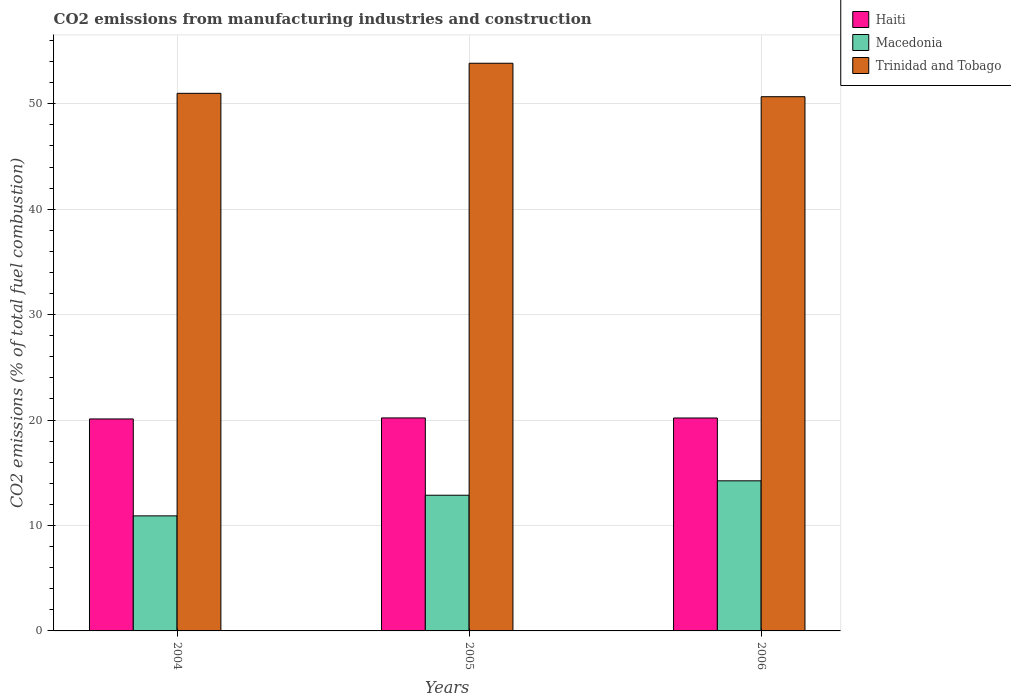How many different coloured bars are there?
Offer a terse response. 3. What is the amount of CO2 emitted in Trinidad and Tobago in 2006?
Keep it short and to the point. 50.67. Across all years, what is the maximum amount of CO2 emitted in Macedonia?
Offer a terse response. 14.24. Across all years, what is the minimum amount of CO2 emitted in Macedonia?
Make the answer very short. 10.91. In which year was the amount of CO2 emitted in Haiti maximum?
Your response must be concise. 2005. What is the total amount of CO2 emitted in Trinidad and Tobago in the graph?
Provide a short and direct response. 155.51. What is the difference between the amount of CO2 emitted in Macedonia in 2005 and that in 2006?
Ensure brevity in your answer.  -1.37. What is the difference between the amount of CO2 emitted in Macedonia in 2005 and the amount of CO2 emitted in Haiti in 2006?
Your response must be concise. -7.33. What is the average amount of CO2 emitted in Trinidad and Tobago per year?
Your answer should be very brief. 51.84. In the year 2005, what is the difference between the amount of CO2 emitted in Macedonia and amount of CO2 emitted in Haiti?
Your answer should be very brief. -7.33. In how many years, is the amount of CO2 emitted in Trinidad and Tobago greater than 48 %?
Offer a very short reply. 3. What is the ratio of the amount of CO2 emitted in Haiti in 2005 to that in 2006?
Offer a terse response. 1. What is the difference between the highest and the second highest amount of CO2 emitted in Macedonia?
Ensure brevity in your answer.  1.37. What is the difference between the highest and the lowest amount of CO2 emitted in Trinidad and Tobago?
Make the answer very short. 3.17. Is the sum of the amount of CO2 emitted in Macedonia in 2005 and 2006 greater than the maximum amount of CO2 emitted in Haiti across all years?
Provide a short and direct response. Yes. What does the 3rd bar from the left in 2004 represents?
Your answer should be compact. Trinidad and Tobago. What does the 2nd bar from the right in 2006 represents?
Your answer should be compact. Macedonia. Are all the bars in the graph horizontal?
Give a very brief answer. No. Are the values on the major ticks of Y-axis written in scientific E-notation?
Provide a succinct answer. No. Does the graph contain any zero values?
Offer a very short reply. No. Does the graph contain grids?
Give a very brief answer. Yes. Where does the legend appear in the graph?
Your response must be concise. Top right. How many legend labels are there?
Give a very brief answer. 3. How are the legend labels stacked?
Your answer should be very brief. Vertical. What is the title of the graph?
Make the answer very short. CO2 emissions from manufacturing industries and construction. What is the label or title of the X-axis?
Your answer should be compact. Years. What is the label or title of the Y-axis?
Provide a succinct answer. CO2 emissions (% of total fuel combustion). What is the CO2 emissions (% of total fuel combustion) in Haiti in 2004?
Your answer should be very brief. 20.11. What is the CO2 emissions (% of total fuel combustion) in Macedonia in 2004?
Provide a short and direct response. 10.91. What is the CO2 emissions (% of total fuel combustion) of Trinidad and Tobago in 2004?
Your answer should be very brief. 50.99. What is the CO2 emissions (% of total fuel combustion) of Haiti in 2005?
Your response must be concise. 20.2. What is the CO2 emissions (% of total fuel combustion) of Macedonia in 2005?
Your response must be concise. 12.87. What is the CO2 emissions (% of total fuel combustion) of Trinidad and Tobago in 2005?
Keep it short and to the point. 53.84. What is the CO2 emissions (% of total fuel combustion) in Haiti in 2006?
Make the answer very short. 20.2. What is the CO2 emissions (% of total fuel combustion) of Macedonia in 2006?
Ensure brevity in your answer.  14.24. What is the CO2 emissions (% of total fuel combustion) of Trinidad and Tobago in 2006?
Ensure brevity in your answer.  50.67. Across all years, what is the maximum CO2 emissions (% of total fuel combustion) in Haiti?
Make the answer very short. 20.2. Across all years, what is the maximum CO2 emissions (% of total fuel combustion) in Macedonia?
Keep it short and to the point. 14.24. Across all years, what is the maximum CO2 emissions (% of total fuel combustion) in Trinidad and Tobago?
Your answer should be compact. 53.84. Across all years, what is the minimum CO2 emissions (% of total fuel combustion) of Haiti?
Keep it short and to the point. 20.11. Across all years, what is the minimum CO2 emissions (% of total fuel combustion) in Macedonia?
Give a very brief answer. 10.91. Across all years, what is the minimum CO2 emissions (% of total fuel combustion) in Trinidad and Tobago?
Your answer should be very brief. 50.67. What is the total CO2 emissions (% of total fuel combustion) in Haiti in the graph?
Give a very brief answer. 60.5. What is the total CO2 emissions (% of total fuel combustion) of Macedonia in the graph?
Provide a succinct answer. 38.02. What is the total CO2 emissions (% of total fuel combustion) in Trinidad and Tobago in the graph?
Make the answer very short. 155.51. What is the difference between the CO2 emissions (% of total fuel combustion) in Haiti in 2004 and that in 2005?
Keep it short and to the point. -0.1. What is the difference between the CO2 emissions (% of total fuel combustion) of Macedonia in 2004 and that in 2005?
Make the answer very short. -1.96. What is the difference between the CO2 emissions (% of total fuel combustion) in Trinidad and Tobago in 2004 and that in 2005?
Offer a very short reply. -2.85. What is the difference between the CO2 emissions (% of total fuel combustion) of Haiti in 2004 and that in 2006?
Your answer should be very brief. -0.09. What is the difference between the CO2 emissions (% of total fuel combustion) in Macedonia in 2004 and that in 2006?
Give a very brief answer. -3.32. What is the difference between the CO2 emissions (% of total fuel combustion) in Trinidad and Tobago in 2004 and that in 2006?
Offer a terse response. 0.32. What is the difference between the CO2 emissions (% of total fuel combustion) of Haiti in 2005 and that in 2006?
Offer a terse response. 0.01. What is the difference between the CO2 emissions (% of total fuel combustion) in Macedonia in 2005 and that in 2006?
Your response must be concise. -1.37. What is the difference between the CO2 emissions (% of total fuel combustion) of Trinidad and Tobago in 2005 and that in 2006?
Keep it short and to the point. 3.17. What is the difference between the CO2 emissions (% of total fuel combustion) in Haiti in 2004 and the CO2 emissions (% of total fuel combustion) in Macedonia in 2005?
Offer a very short reply. 7.24. What is the difference between the CO2 emissions (% of total fuel combustion) in Haiti in 2004 and the CO2 emissions (% of total fuel combustion) in Trinidad and Tobago in 2005?
Give a very brief answer. -33.74. What is the difference between the CO2 emissions (% of total fuel combustion) of Macedonia in 2004 and the CO2 emissions (% of total fuel combustion) of Trinidad and Tobago in 2005?
Your response must be concise. -42.93. What is the difference between the CO2 emissions (% of total fuel combustion) in Haiti in 2004 and the CO2 emissions (% of total fuel combustion) in Macedonia in 2006?
Make the answer very short. 5.87. What is the difference between the CO2 emissions (% of total fuel combustion) of Haiti in 2004 and the CO2 emissions (% of total fuel combustion) of Trinidad and Tobago in 2006?
Your response must be concise. -30.56. What is the difference between the CO2 emissions (% of total fuel combustion) of Macedonia in 2004 and the CO2 emissions (% of total fuel combustion) of Trinidad and Tobago in 2006?
Ensure brevity in your answer.  -39.76. What is the difference between the CO2 emissions (% of total fuel combustion) of Haiti in 2005 and the CO2 emissions (% of total fuel combustion) of Macedonia in 2006?
Ensure brevity in your answer.  5.97. What is the difference between the CO2 emissions (% of total fuel combustion) in Haiti in 2005 and the CO2 emissions (% of total fuel combustion) in Trinidad and Tobago in 2006?
Make the answer very short. -30.47. What is the difference between the CO2 emissions (% of total fuel combustion) in Macedonia in 2005 and the CO2 emissions (% of total fuel combustion) in Trinidad and Tobago in 2006?
Keep it short and to the point. -37.8. What is the average CO2 emissions (% of total fuel combustion) in Haiti per year?
Your answer should be compact. 20.17. What is the average CO2 emissions (% of total fuel combustion) of Macedonia per year?
Your answer should be compact. 12.67. What is the average CO2 emissions (% of total fuel combustion) of Trinidad and Tobago per year?
Your response must be concise. 51.84. In the year 2004, what is the difference between the CO2 emissions (% of total fuel combustion) in Haiti and CO2 emissions (% of total fuel combustion) in Macedonia?
Provide a succinct answer. 9.19. In the year 2004, what is the difference between the CO2 emissions (% of total fuel combustion) of Haiti and CO2 emissions (% of total fuel combustion) of Trinidad and Tobago?
Keep it short and to the point. -30.89. In the year 2004, what is the difference between the CO2 emissions (% of total fuel combustion) of Macedonia and CO2 emissions (% of total fuel combustion) of Trinidad and Tobago?
Offer a very short reply. -40.08. In the year 2005, what is the difference between the CO2 emissions (% of total fuel combustion) in Haiti and CO2 emissions (% of total fuel combustion) in Macedonia?
Your answer should be compact. 7.33. In the year 2005, what is the difference between the CO2 emissions (% of total fuel combustion) of Haiti and CO2 emissions (% of total fuel combustion) of Trinidad and Tobago?
Offer a very short reply. -33.64. In the year 2005, what is the difference between the CO2 emissions (% of total fuel combustion) of Macedonia and CO2 emissions (% of total fuel combustion) of Trinidad and Tobago?
Offer a very short reply. -40.97. In the year 2006, what is the difference between the CO2 emissions (% of total fuel combustion) of Haiti and CO2 emissions (% of total fuel combustion) of Macedonia?
Offer a very short reply. 5.96. In the year 2006, what is the difference between the CO2 emissions (% of total fuel combustion) in Haiti and CO2 emissions (% of total fuel combustion) in Trinidad and Tobago?
Your answer should be very brief. -30.47. In the year 2006, what is the difference between the CO2 emissions (% of total fuel combustion) in Macedonia and CO2 emissions (% of total fuel combustion) in Trinidad and Tobago?
Offer a terse response. -36.43. What is the ratio of the CO2 emissions (% of total fuel combustion) of Haiti in 2004 to that in 2005?
Make the answer very short. 1. What is the ratio of the CO2 emissions (% of total fuel combustion) of Macedonia in 2004 to that in 2005?
Provide a short and direct response. 0.85. What is the ratio of the CO2 emissions (% of total fuel combustion) of Trinidad and Tobago in 2004 to that in 2005?
Provide a short and direct response. 0.95. What is the ratio of the CO2 emissions (% of total fuel combustion) of Macedonia in 2004 to that in 2006?
Keep it short and to the point. 0.77. What is the ratio of the CO2 emissions (% of total fuel combustion) of Trinidad and Tobago in 2004 to that in 2006?
Your answer should be compact. 1.01. What is the ratio of the CO2 emissions (% of total fuel combustion) of Haiti in 2005 to that in 2006?
Give a very brief answer. 1. What is the ratio of the CO2 emissions (% of total fuel combustion) in Macedonia in 2005 to that in 2006?
Make the answer very short. 0.9. What is the ratio of the CO2 emissions (% of total fuel combustion) in Trinidad and Tobago in 2005 to that in 2006?
Offer a terse response. 1.06. What is the difference between the highest and the second highest CO2 emissions (% of total fuel combustion) of Haiti?
Make the answer very short. 0.01. What is the difference between the highest and the second highest CO2 emissions (% of total fuel combustion) in Macedonia?
Ensure brevity in your answer.  1.37. What is the difference between the highest and the second highest CO2 emissions (% of total fuel combustion) of Trinidad and Tobago?
Your answer should be very brief. 2.85. What is the difference between the highest and the lowest CO2 emissions (% of total fuel combustion) of Haiti?
Your answer should be very brief. 0.1. What is the difference between the highest and the lowest CO2 emissions (% of total fuel combustion) in Macedonia?
Ensure brevity in your answer.  3.32. What is the difference between the highest and the lowest CO2 emissions (% of total fuel combustion) of Trinidad and Tobago?
Keep it short and to the point. 3.17. 